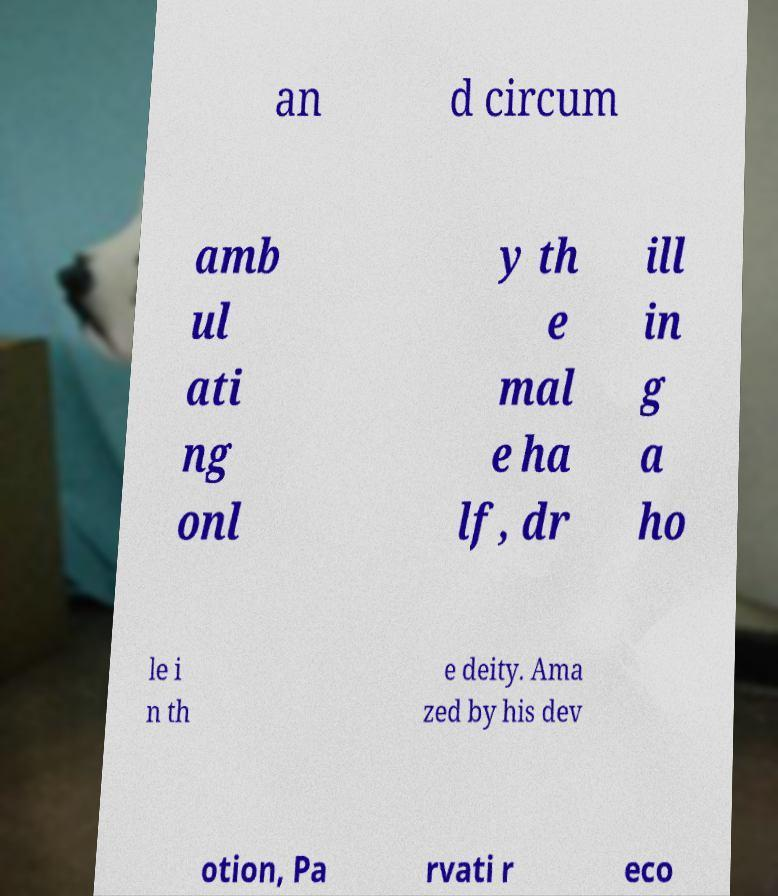Please read and relay the text visible in this image. What does it say? an d circum amb ul ati ng onl y th e mal e ha lf, dr ill in g a ho le i n th e deity. Ama zed by his dev otion, Pa rvati r eco 